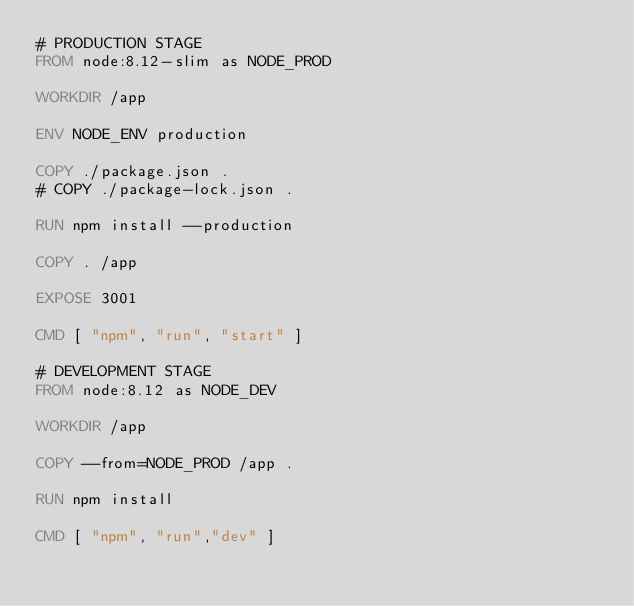<code> <loc_0><loc_0><loc_500><loc_500><_Dockerfile_># PRODUCTION STAGE
FROM node:8.12-slim as NODE_PROD

WORKDIR /app

ENV NODE_ENV production

COPY ./package.json .
# COPY ./package-lock.json .

RUN npm install --production

COPY . /app

EXPOSE 3001

CMD [ "npm", "run", "start" ]

# DEVELOPMENT STAGE
FROM node:8.12 as NODE_DEV

WORKDIR /app

COPY --from=NODE_PROD /app .

RUN npm install

CMD [ "npm", "run","dev" ]</code> 